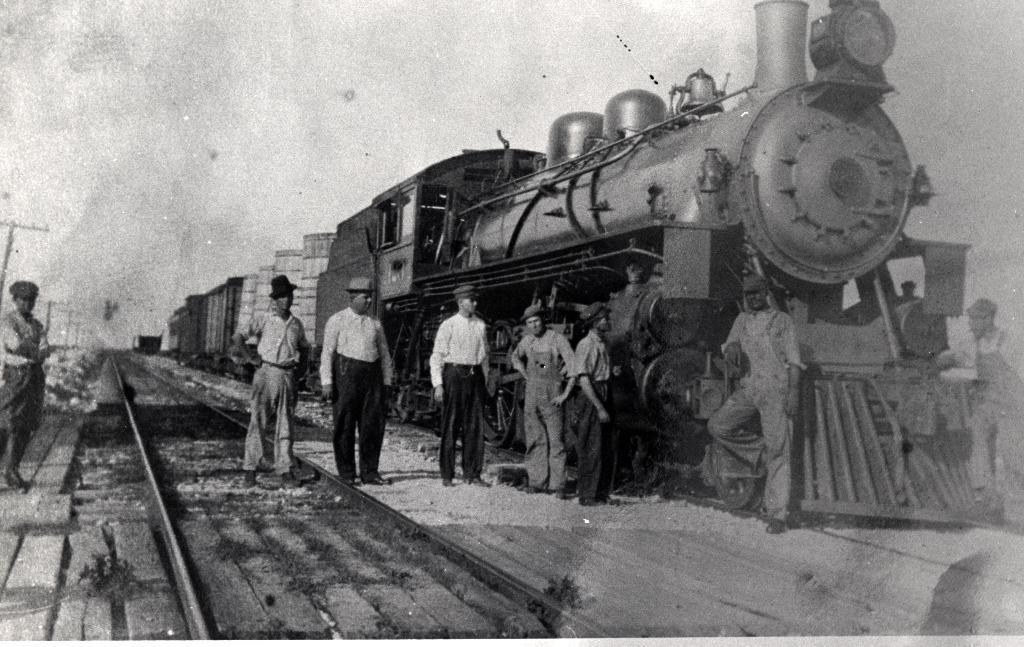How would you summarize this image in a sentence or two? In this picture there is a old image of train engine. In the front there is a group of workers standing and looking in the camera. On the left side there is a train track. 